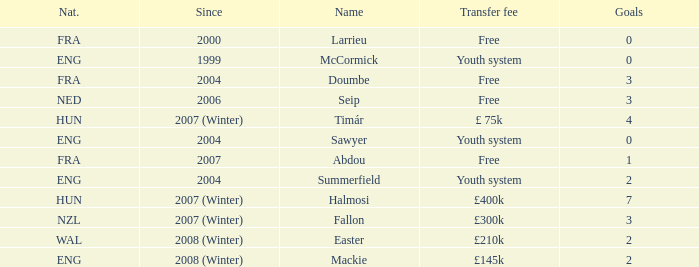For the player who has scored more than 3 goals and was transferred for £400k, what is their starting year? 2007 (Winter). Give me the full table as a dictionary. {'header': ['Nat.', 'Since', 'Name', 'Transfer fee', 'Goals'], 'rows': [['FRA', '2000', 'Larrieu', 'Free', '0'], ['ENG', '1999', 'McCormick', 'Youth system', '0'], ['FRA', '2004', 'Doumbe', 'Free', '3'], ['NED', '2006', 'Seip', 'Free', '3'], ['HUN', '2007 (Winter)', 'Timár', '£ 75k', '4'], ['ENG', '2004', 'Sawyer', 'Youth system', '0'], ['FRA', '2007', 'Abdou', 'Free', '1'], ['ENG', '2004', 'Summerfield', 'Youth system', '2'], ['HUN', '2007 (Winter)', 'Halmosi', '£400k', '7'], ['NZL', '2007 (Winter)', 'Fallon', '£300k', '3'], ['WAL', '2008 (Winter)', 'Easter', '£210k', '2'], ['ENG', '2008 (Winter)', 'Mackie', '£145k', '2']]} 